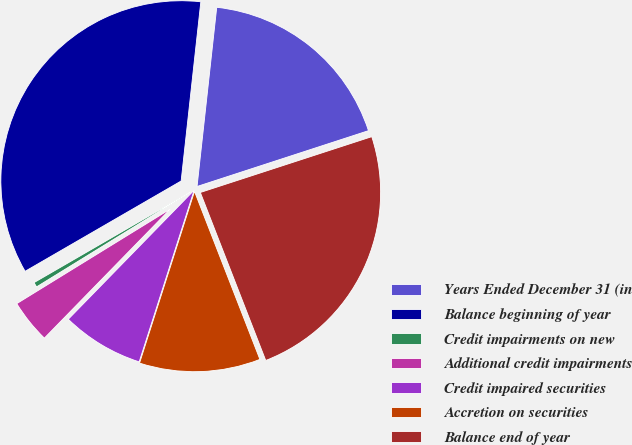<chart> <loc_0><loc_0><loc_500><loc_500><pie_chart><fcel>Years Ended December 31 (in<fcel>Balance beginning of year<fcel>Credit impairments on new<fcel>Additional credit impairments<fcel>Credit impaired securities<fcel>Accretion on securities<fcel>Balance end of year<nl><fcel>18.25%<fcel>35.09%<fcel>0.44%<fcel>3.91%<fcel>7.37%<fcel>10.84%<fcel>24.1%<nl></chart> 